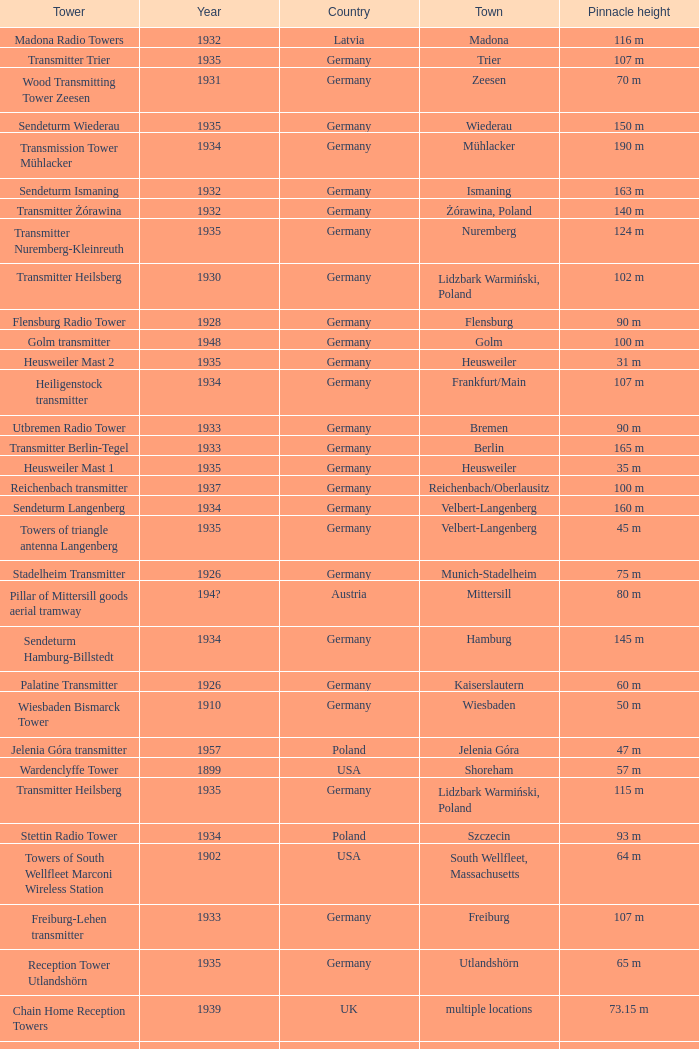Which country had a tower destroyed in 1899? USA. 